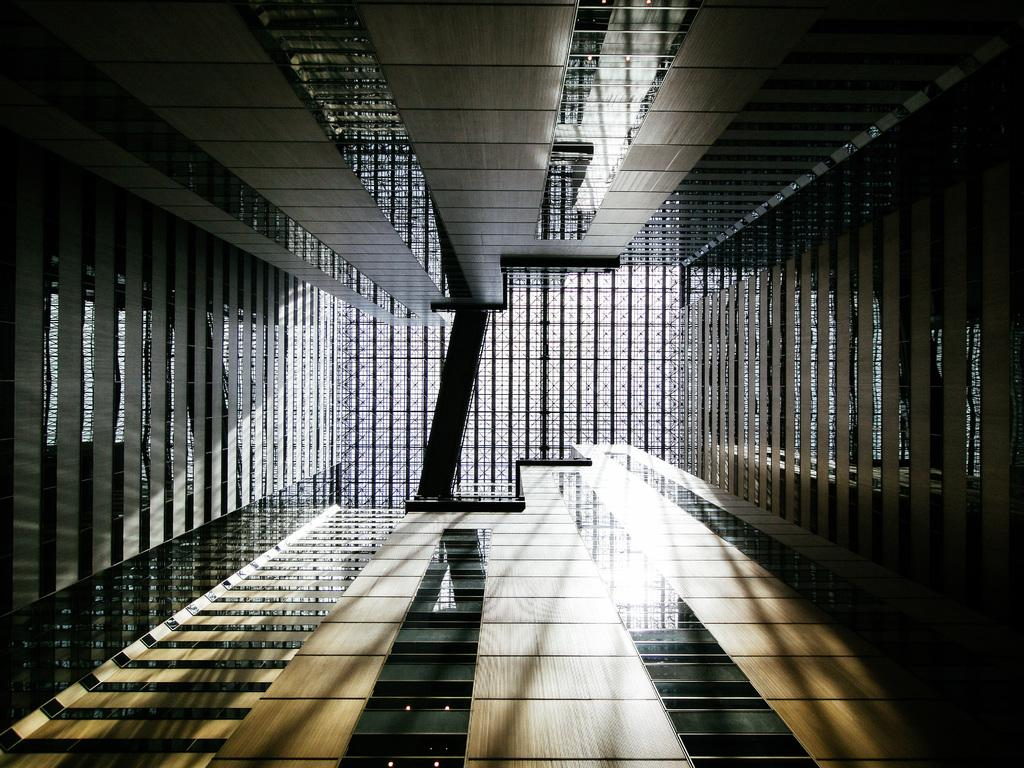What type of structures can be seen in the image? There are buildings in the image. What colors are the buildings in the image? The buildings are in black and brown color. What is the taste of the lumber in the image? There is no lumber present in the image, and therefore no taste can be determined. 